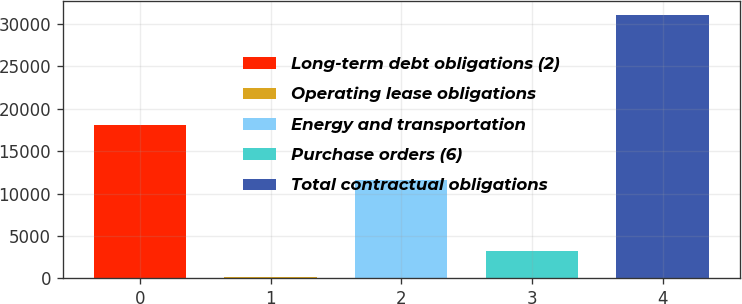Convert chart. <chart><loc_0><loc_0><loc_500><loc_500><bar_chart><fcel>Long-term debt obligations (2)<fcel>Operating lease obligations<fcel>Energy and transportation<fcel>Purchase orders (6)<fcel>Total contractual obligations<nl><fcel>18025.9<fcel>115.1<fcel>11640.9<fcel>3210.68<fcel>31070.9<nl></chart> 